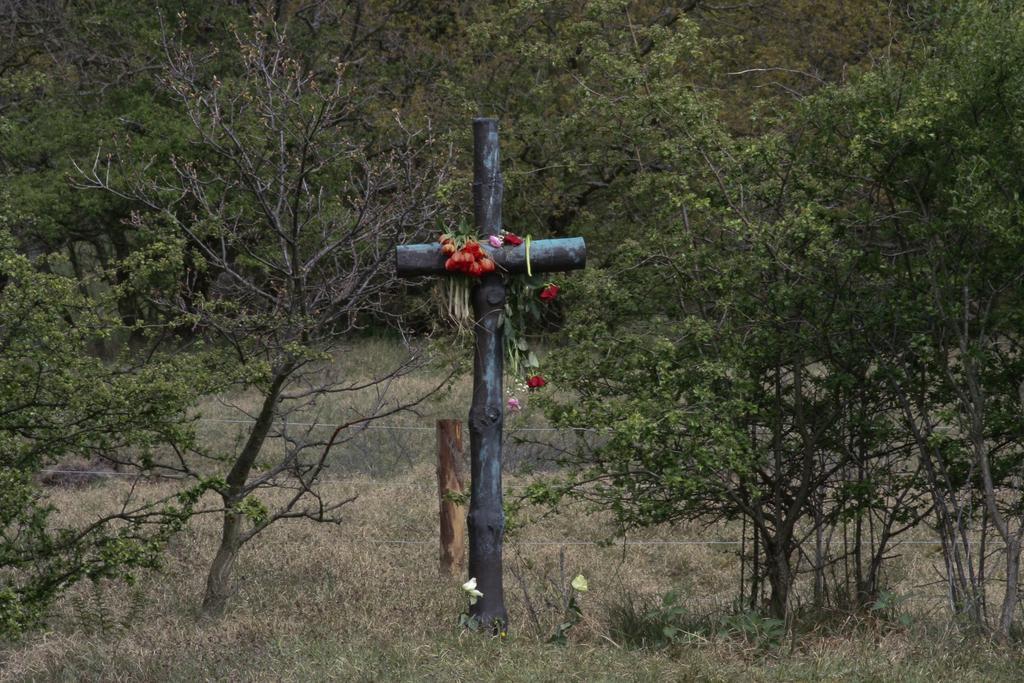Please provide a concise description of this image. In this image we can see a cross in the grass with some flowers over it, there we can also see few trees, plants, cables and a wooden stick. 